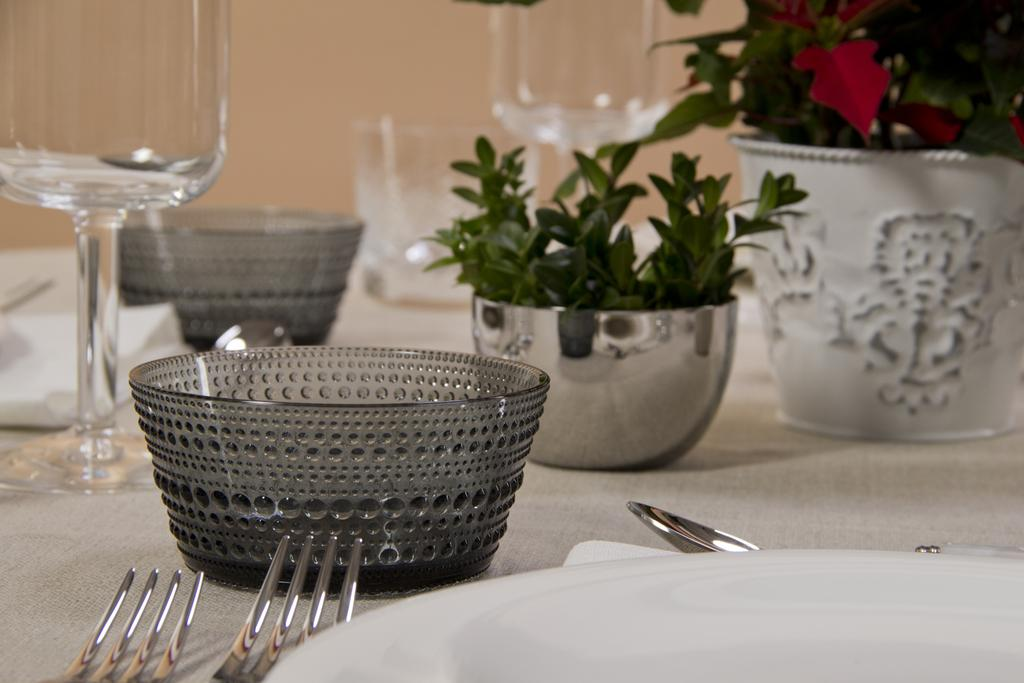What type of objects can be seen in the image? There are plants, bowls, plates, forks, spoons, and glasses in the image. Can you describe the tableware in the image? There are bowls, plates, forks, spoons, and glasses in the image. What might be used for eating and drinking in the image? The forks, spoons, and glasses in the image can be used for eating and drinking. What type of suit is visible on the plants in the image? There are no suits present in the image, as it features plants, bowls, plates, forks, spoons, and glasses. How many mittens can be seen on the forks in the image? There are no mittens present in the image, as it features plants, bowls, plates, forks, spoons, and glasses. 